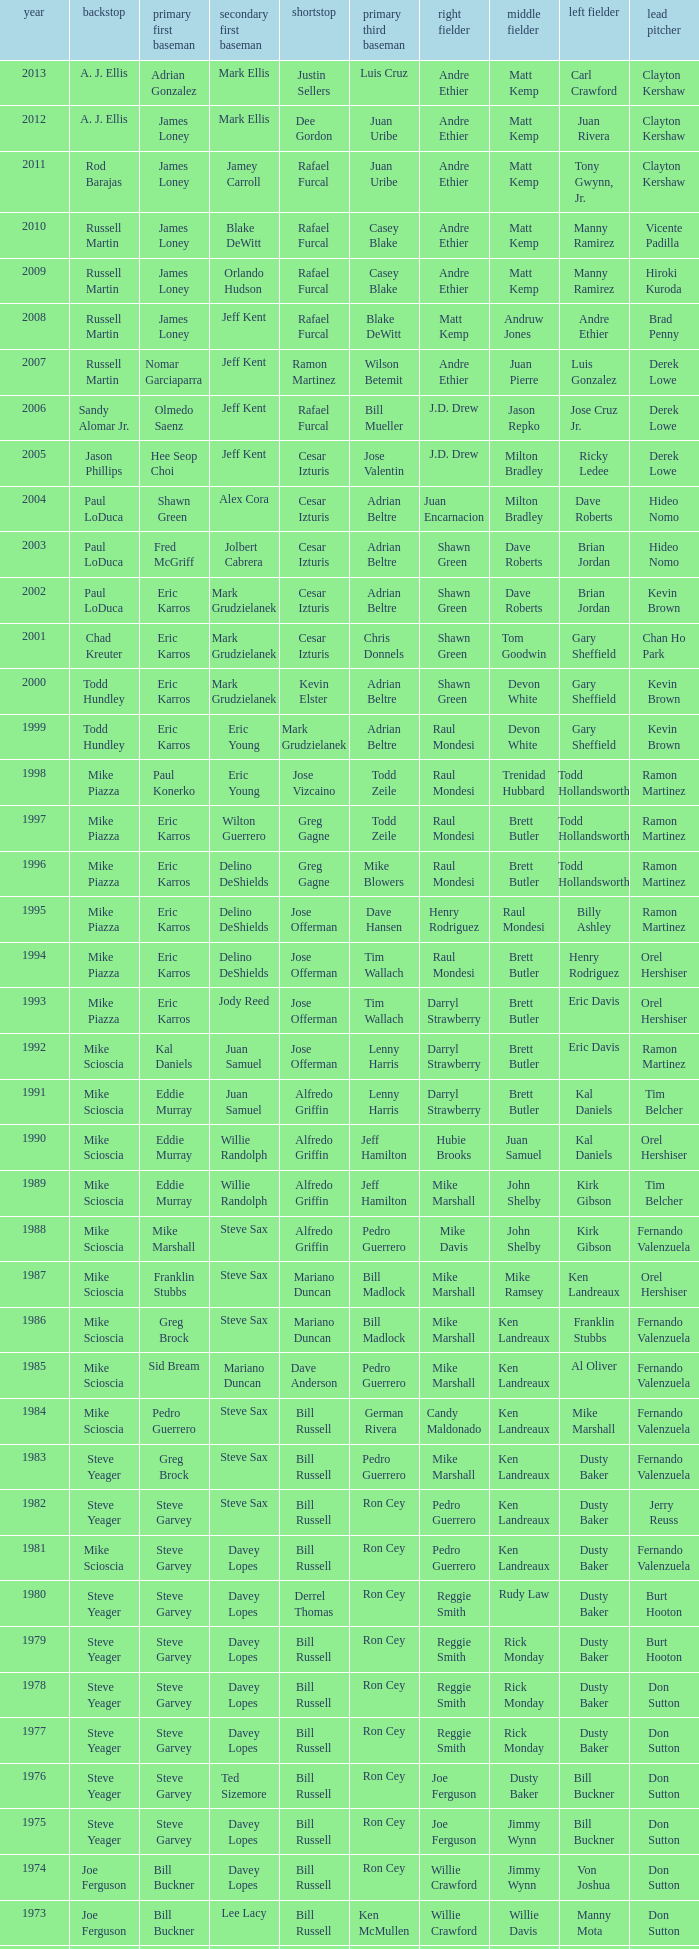Who was the RF when the SP was vicente padilla? Andre Ethier. 